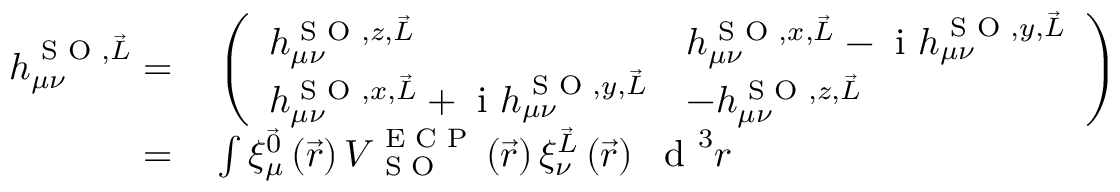<formula> <loc_0><loc_0><loc_500><loc_500>\begin{array} { r l } { h _ { \mu \nu } ^ { S O , \vec { L } } = } & \left ( \begin{array} { l l } { h _ { \mu \nu } ^ { S O , z , \vec { L } } } & { h _ { \mu \nu } ^ { S O , x , \vec { L } } - i h _ { \mu \nu } ^ { S O , y , \vec { L } } } \\ { h _ { \mu \nu } ^ { S O , x , \vec { L } } + i h _ { \mu \nu } ^ { S O , y , \vec { L } } } & { - h _ { \mu \nu } ^ { S O , z , \vec { L } } } \end{array} \right ) } \\ { = } & \int \xi _ { \mu } ^ { \vec { 0 } } \left ( \vec { r } \right ) V _ { S O } ^ { E C P } \left ( \vec { r } \right ) \xi _ { \nu } ^ { \vec { L } } \left ( \vec { r } \right ) d ^ { 3 } r } \end{array}</formula> 